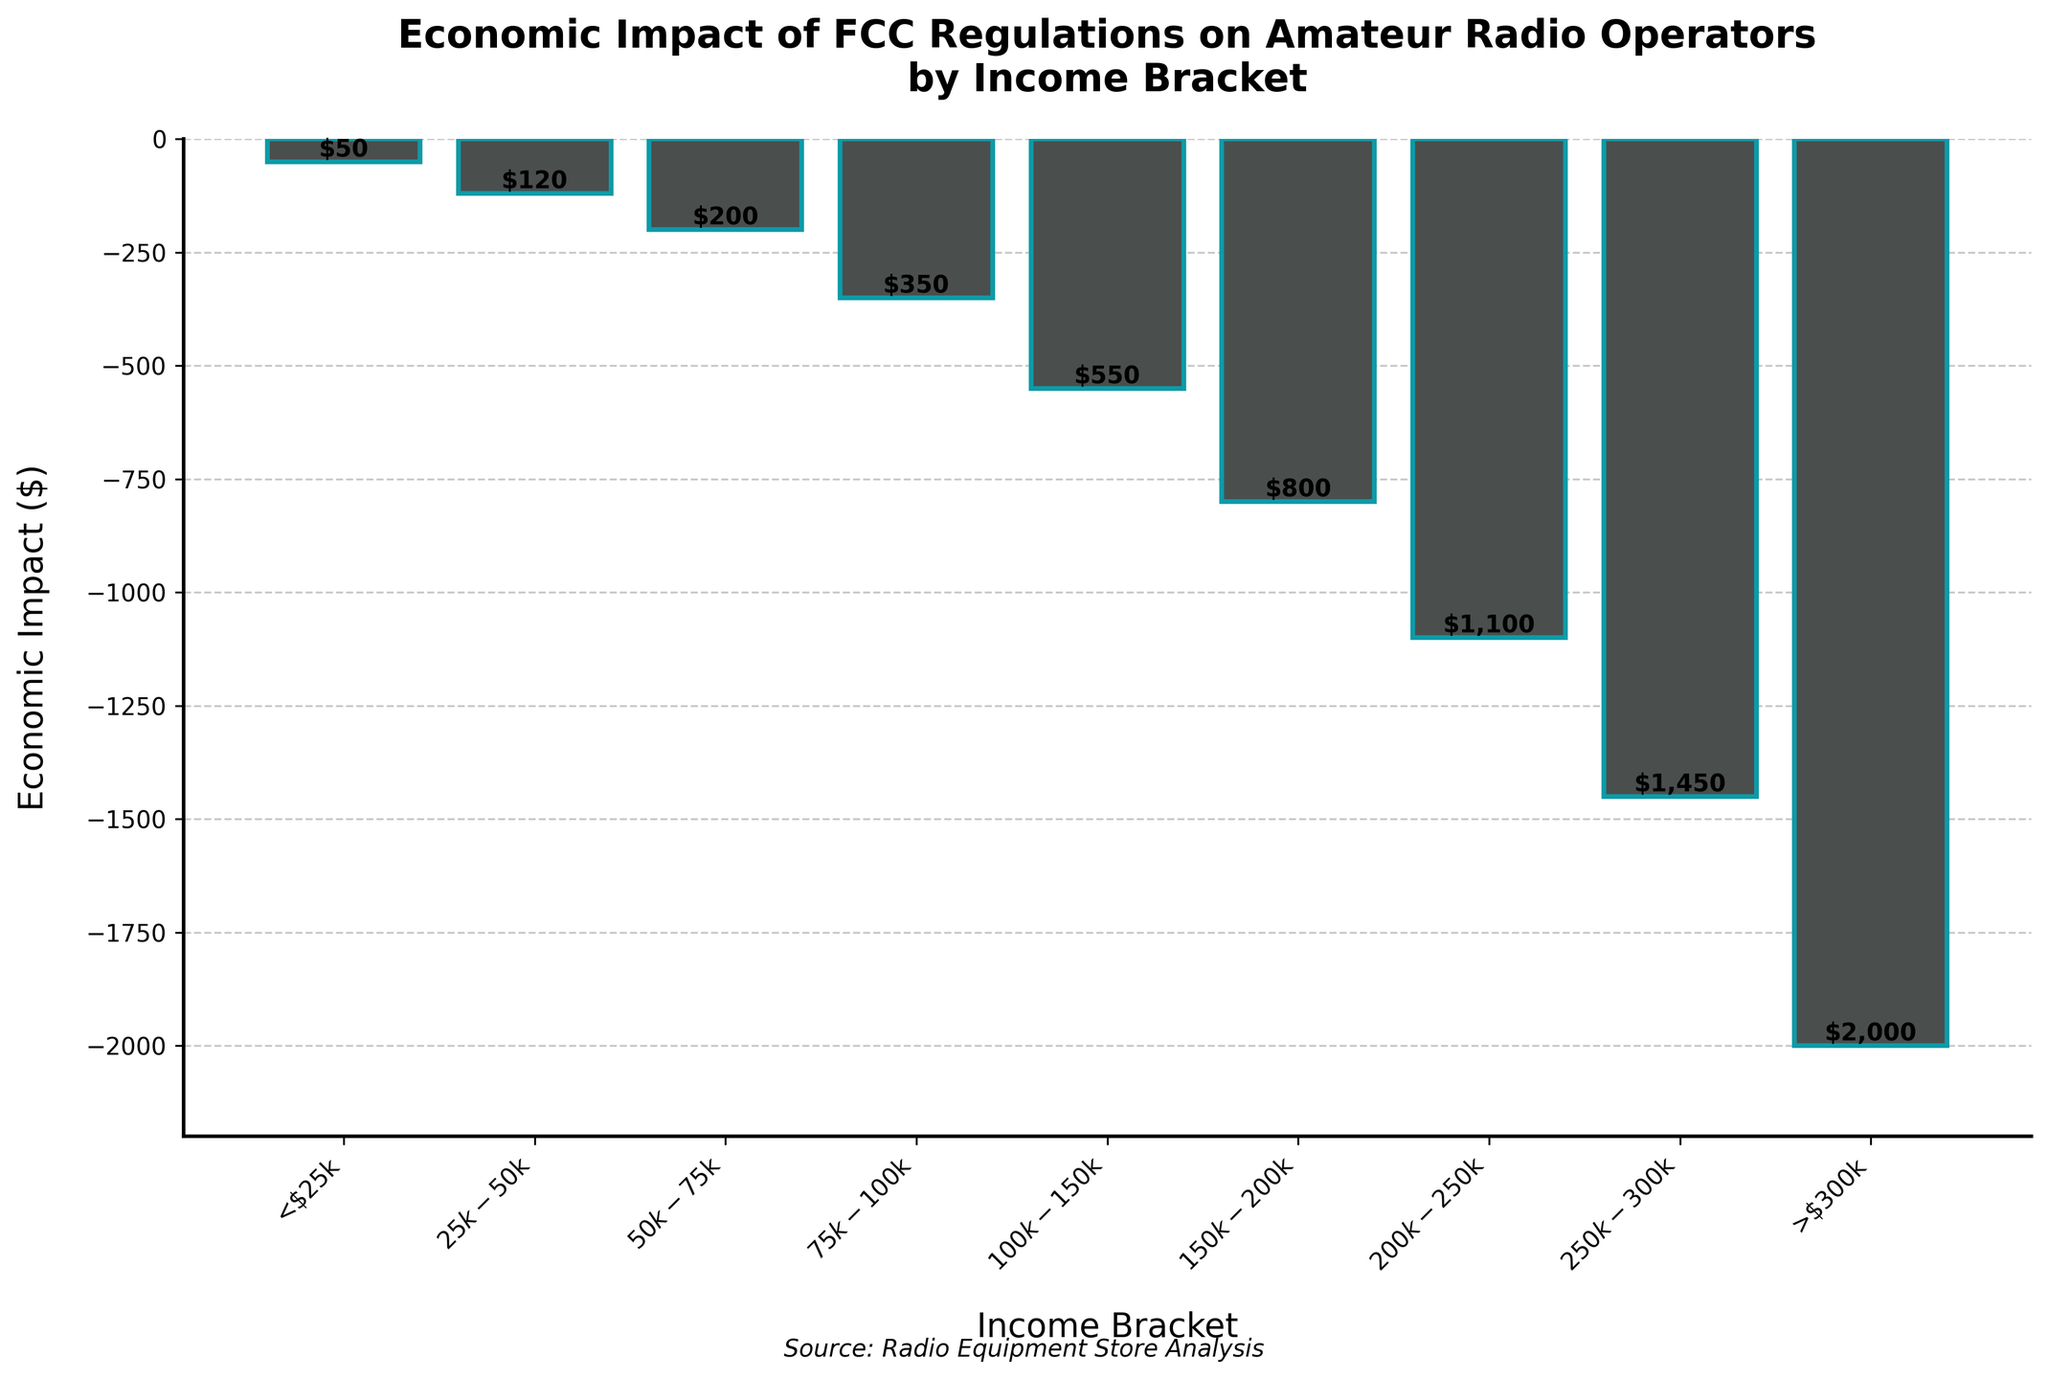What is the economic impact for the income bracket of $50k-$75k? Locate the bar corresponding to the $50k-$75k income bracket. The height of the bar represents the economic impact. According to the figure, the bar's label indicates an economic impact of -$200.
Answer: -$200 Which income bracket experiences the highest economic impact? Identify the tallest bar in the chart. The tallest bar corresponds to the income bracket of >$300k, with an economic impact of -$2000.
Answer: >$300k How does the economic impact for the $150k-$200k income bracket compare to that of the <$25k bracket? Compare the heights of the bars for $150k-$200k and <$25k. The economic impact for income bracket $150k-$200k is -$800, while <$25k is -$50. Thus, the economic impact is more severe for $150k-$200k.
Answer: $150k-$200k has a higher economic impact What is the sum of the economic impacts for all income brackets below $100k? Sum the economic impacts for the <$25k, $25k-$50k, $50k-$75k, and $75k-$100k brackets: -50 + -120 + -200 + -350 = -720.
Answer: -$720 Which income bracket has an economic impact closest to -$500? Locate the bars closest to -$500. The $100k-$150k bracket has an economic impact of -$550, which is the closest impact to -$500.
Answer: $100k-$150k How many income brackets have an economic impact greater than -$1000? Count the bars with an economic impact less negative (closer to zero) than -$1000. Brackets <$25k, $25k-$50k, $50k-$75k, $75k-$100k, $100k-$150k, and $150k-$200k all have impacts greater than -$1000.
Answer: 6 By how much does the economic impact increase from the $75k-$100k bracket to the $100k-$150k bracket? Determine the difference in economic impact between $100k-$150k and $75k-$100k: -550 - (-350) = -200. The impact increases by -$200.
Answer: -$200 Which income bracket shows the smallest economic impact, and what is the value? Identify the bar with the smallest (least negative) economic impact. The <$25k bracket has the smallest impact at -$50.
Answer: <$25k, -$50 What is the average economic impact across all income brackets? Calculate the average of all economic impacts: (-50 + -120 + -200 + -350 + -550 + -800 + -1100 + -1450 + -2000) / 9 = -746.67.
Answer: -$746.67 